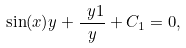<formula> <loc_0><loc_0><loc_500><loc_500>\sin ( x ) y + { \frac { \ y 1 } { y } } + C _ { 1 } = 0 ,</formula> 